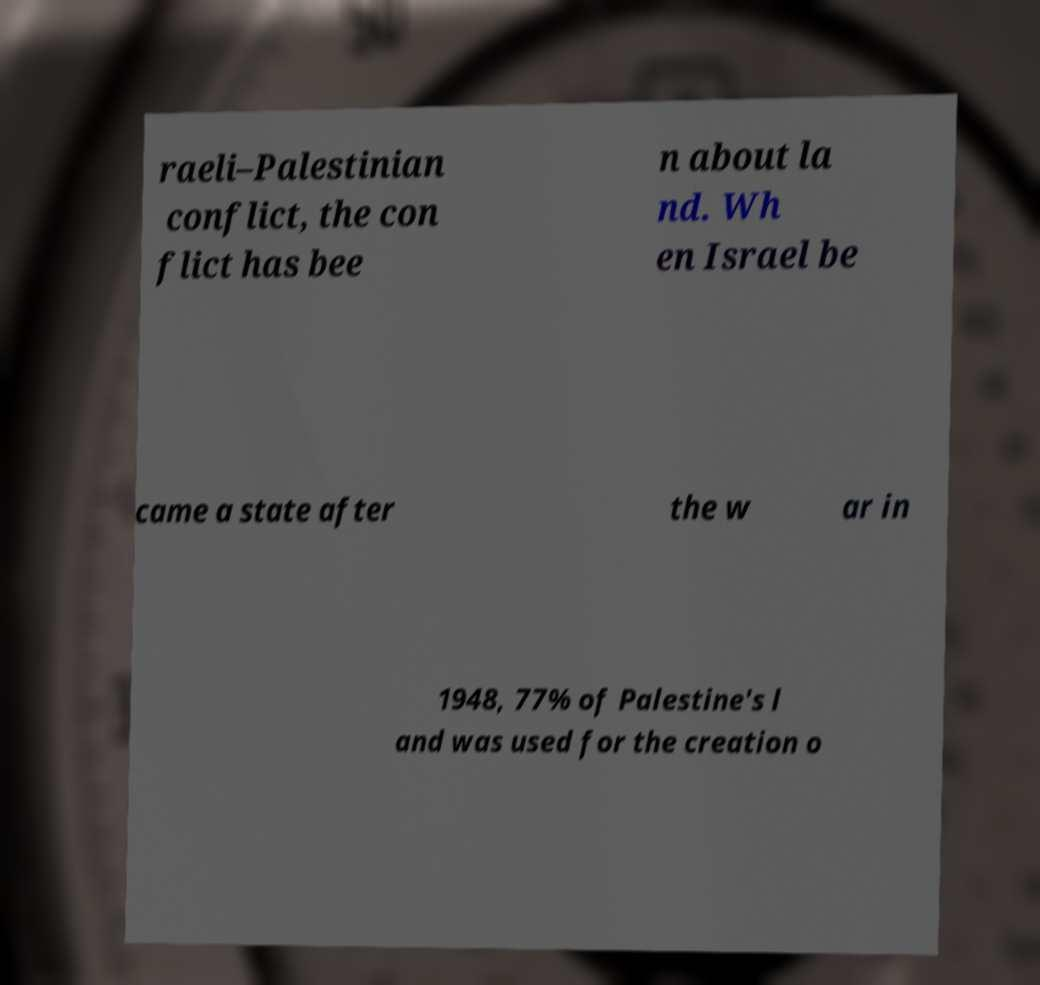What messages or text are displayed in this image? I need them in a readable, typed format. raeli–Palestinian conflict, the con flict has bee n about la nd. Wh en Israel be came a state after the w ar in 1948, 77% of Palestine's l and was used for the creation o 